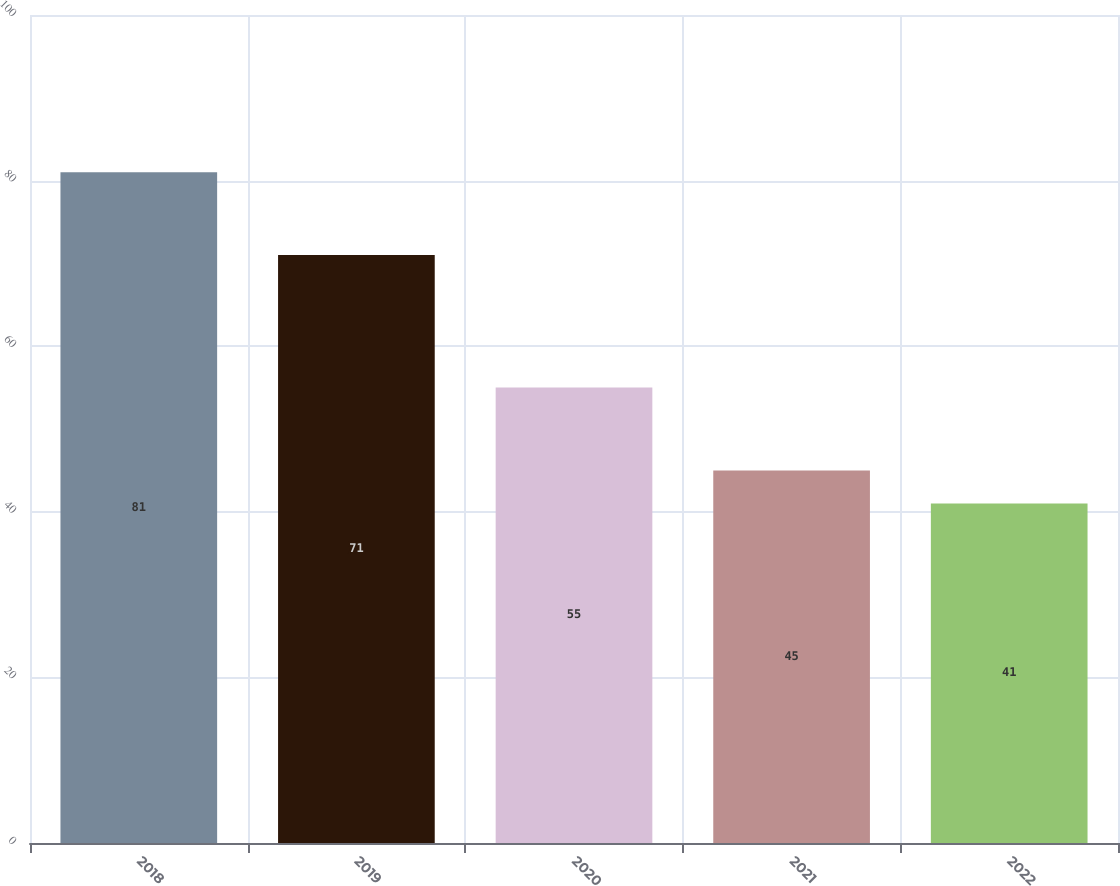Convert chart to OTSL. <chart><loc_0><loc_0><loc_500><loc_500><bar_chart><fcel>2018<fcel>2019<fcel>2020<fcel>2021<fcel>2022<nl><fcel>81<fcel>71<fcel>55<fcel>45<fcel>41<nl></chart> 